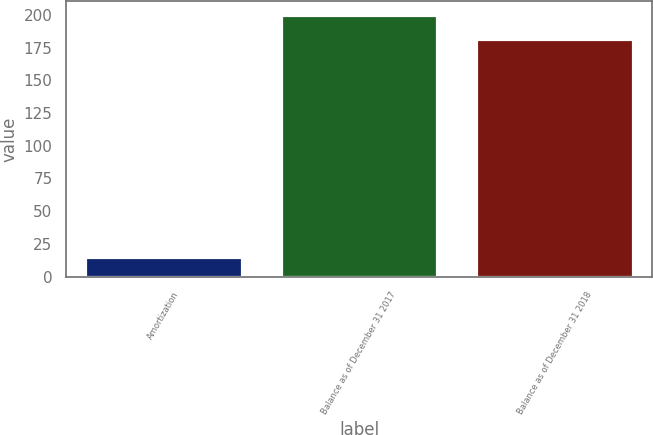Convert chart to OTSL. <chart><loc_0><loc_0><loc_500><loc_500><bar_chart><fcel>Amortization<fcel>Balance as of December 31 2017<fcel>Balance as of December 31 2018<nl><fcel>15.1<fcel>200.26<fcel>181.9<nl></chart> 